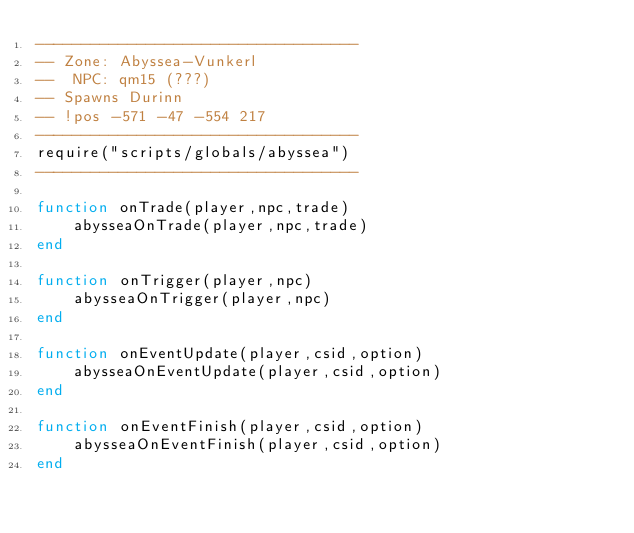<code> <loc_0><loc_0><loc_500><loc_500><_Lua_>-----------------------------------
-- Zone: Abyssea-Vunkerl
--  NPC: qm15 (???)
-- Spawns Durinn
-- !pos -571 -47 -554 217
-----------------------------------
require("scripts/globals/abyssea")
-----------------------------------

function onTrade(player,npc,trade)
    abysseaOnTrade(player,npc,trade)
end

function onTrigger(player,npc)
    abysseaOnTrigger(player,npc)
end

function onEventUpdate(player,csid,option)
    abysseaOnEventUpdate(player,csid,option)
end

function onEventFinish(player,csid,option)
    abysseaOnEventFinish(player,csid,option)
end
</code> 